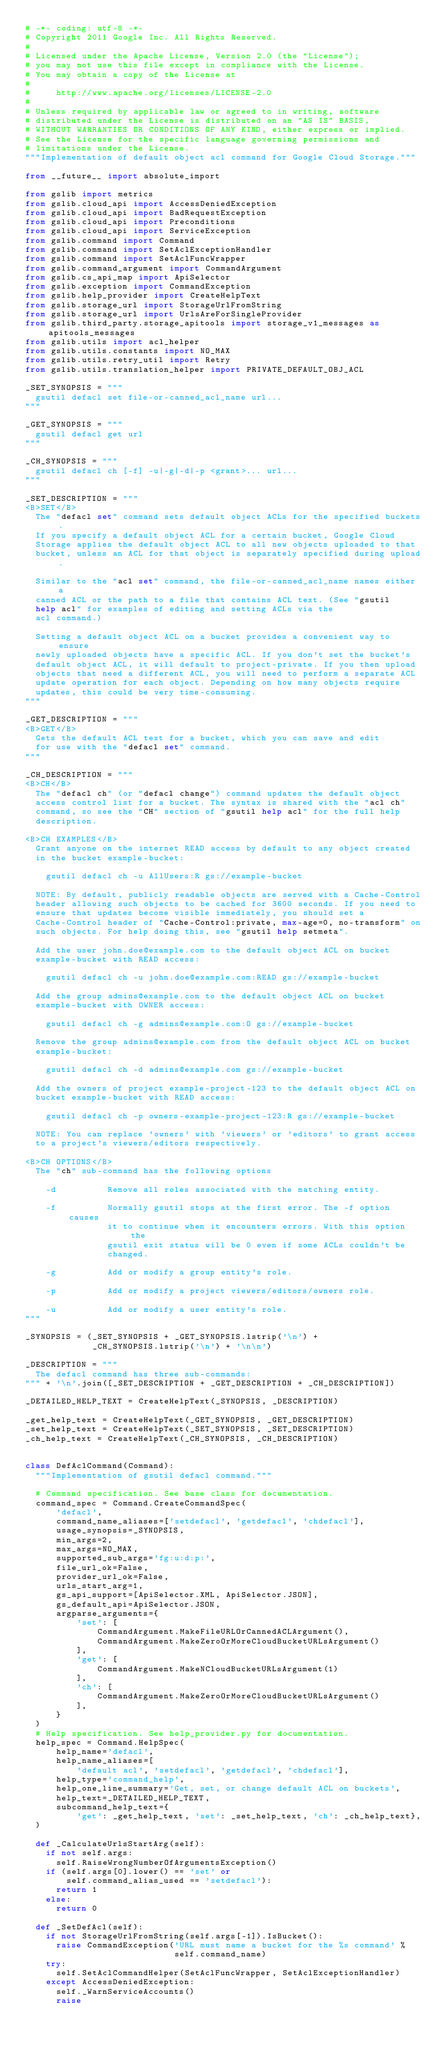<code> <loc_0><loc_0><loc_500><loc_500><_Python_># -*- coding: utf-8 -*-
# Copyright 2011 Google Inc. All Rights Reserved.
#
# Licensed under the Apache License, Version 2.0 (the "License");
# you may not use this file except in compliance with the License.
# You may obtain a copy of the License at
#
#     http://www.apache.org/licenses/LICENSE-2.0
#
# Unless required by applicable law or agreed to in writing, software
# distributed under the License is distributed on an "AS IS" BASIS,
# WITHOUT WARRANTIES OR CONDITIONS OF ANY KIND, either express or implied.
# See the License for the specific language governing permissions and
# limitations under the License.
"""Implementation of default object acl command for Google Cloud Storage."""

from __future__ import absolute_import

from gslib import metrics
from gslib.cloud_api import AccessDeniedException
from gslib.cloud_api import BadRequestException
from gslib.cloud_api import Preconditions
from gslib.cloud_api import ServiceException
from gslib.command import Command
from gslib.command import SetAclExceptionHandler
from gslib.command import SetAclFuncWrapper
from gslib.command_argument import CommandArgument
from gslib.cs_api_map import ApiSelector
from gslib.exception import CommandException
from gslib.help_provider import CreateHelpText
from gslib.storage_url import StorageUrlFromString
from gslib.storage_url import UrlsAreForSingleProvider
from gslib.third_party.storage_apitools import storage_v1_messages as apitools_messages
from gslib.utils import acl_helper
from gslib.utils.constants import NO_MAX
from gslib.utils.retry_util import Retry
from gslib.utils.translation_helper import PRIVATE_DEFAULT_OBJ_ACL

_SET_SYNOPSIS = """
  gsutil defacl set file-or-canned_acl_name url...
"""

_GET_SYNOPSIS = """
  gsutil defacl get url
"""

_CH_SYNOPSIS = """
  gsutil defacl ch [-f] -u|-g|-d|-p <grant>... url...
"""

_SET_DESCRIPTION = """
<B>SET</B>
  The "defacl set" command sets default object ACLs for the specified buckets.
  If you specify a default object ACL for a certain bucket, Google Cloud
  Storage applies the default object ACL to all new objects uploaded to that
  bucket, unless an ACL for that object is separately specified during upload.

  Similar to the "acl set" command, the file-or-canned_acl_name names either a
  canned ACL or the path to a file that contains ACL text. (See "gsutil
  help acl" for examples of editing and setting ACLs via the
  acl command.)

  Setting a default object ACL on a bucket provides a convenient way to ensure
  newly uploaded objects have a specific ACL. If you don't set the bucket's
  default object ACL, it will default to project-private. If you then upload
  objects that need a different ACL, you will need to perform a separate ACL
  update operation for each object. Depending on how many objects require
  updates, this could be very time-consuming.
"""

_GET_DESCRIPTION = """
<B>GET</B>
  Gets the default ACL text for a bucket, which you can save and edit
  for use with the "defacl set" command.
"""

_CH_DESCRIPTION = """
<B>CH</B>
  The "defacl ch" (or "defacl change") command updates the default object
  access control list for a bucket. The syntax is shared with the "acl ch"
  command, so see the "CH" section of "gsutil help acl" for the full help
  description.

<B>CH EXAMPLES</B>
  Grant anyone on the internet READ access by default to any object created
  in the bucket example-bucket:

    gsutil defacl ch -u AllUsers:R gs://example-bucket

  NOTE: By default, publicly readable objects are served with a Cache-Control
  header allowing such objects to be cached for 3600 seconds. If you need to
  ensure that updates become visible immediately, you should set a
  Cache-Control header of "Cache-Control:private, max-age=0, no-transform" on
  such objects. For help doing this, see "gsutil help setmeta".

  Add the user john.doe@example.com to the default object ACL on bucket
  example-bucket with READ access:

    gsutil defacl ch -u john.doe@example.com:READ gs://example-bucket

  Add the group admins@example.com to the default object ACL on bucket
  example-bucket with OWNER access:

    gsutil defacl ch -g admins@example.com:O gs://example-bucket

  Remove the group admins@example.com from the default object ACL on bucket
  example-bucket:

    gsutil defacl ch -d admins@example.com gs://example-bucket

  Add the owners of project example-project-123 to the default object ACL on
  bucket example-bucket with READ access:

    gsutil defacl ch -p owners-example-project-123:R gs://example-bucket

  NOTE: You can replace 'owners' with 'viewers' or 'editors' to grant access
  to a project's viewers/editors respectively.

<B>CH OPTIONS</B>
  The "ch" sub-command has the following options

    -d          Remove all roles associated with the matching entity.

    -f          Normally gsutil stops at the first error. The -f option causes
                it to continue when it encounters errors. With this option the
                gsutil exit status will be 0 even if some ACLs couldn't be
                changed.

    -g          Add or modify a group entity's role.

    -p          Add or modify a project viewers/editors/owners role.

    -u          Add or modify a user entity's role.
"""

_SYNOPSIS = (_SET_SYNOPSIS + _GET_SYNOPSIS.lstrip('\n') +
             _CH_SYNOPSIS.lstrip('\n') + '\n\n')

_DESCRIPTION = """
  The defacl command has three sub-commands:
""" + '\n'.join([_SET_DESCRIPTION + _GET_DESCRIPTION + _CH_DESCRIPTION])

_DETAILED_HELP_TEXT = CreateHelpText(_SYNOPSIS, _DESCRIPTION)

_get_help_text = CreateHelpText(_GET_SYNOPSIS, _GET_DESCRIPTION)
_set_help_text = CreateHelpText(_SET_SYNOPSIS, _SET_DESCRIPTION)
_ch_help_text = CreateHelpText(_CH_SYNOPSIS, _CH_DESCRIPTION)


class DefAclCommand(Command):
  """Implementation of gsutil defacl command."""

  # Command specification. See base class for documentation.
  command_spec = Command.CreateCommandSpec(
      'defacl',
      command_name_aliases=['setdefacl', 'getdefacl', 'chdefacl'],
      usage_synopsis=_SYNOPSIS,
      min_args=2,
      max_args=NO_MAX,
      supported_sub_args='fg:u:d:p:',
      file_url_ok=False,
      provider_url_ok=False,
      urls_start_arg=1,
      gs_api_support=[ApiSelector.XML, ApiSelector.JSON],
      gs_default_api=ApiSelector.JSON,
      argparse_arguments={
          'set': [
              CommandArgument.MakeFileURLOrCannedACLArgument(),
              CommandArgument.MakeZeroOrMoreCloudBucketURLsArgument()
          ],
          'get': [
              CommandArgument.MakeNCloudBucketURLsArgument(1)
          ],
          'ch': [
              CommandArgument.MakeZeroOrMoreCloudBucketURLsArgument()
          ],
      }
  )
  # Help specification. See help_provider.py for documentation.
  help_spec = Command.HelpSpec(
      help_name='defacl',
      help_name_aliases=[
          'default acl', 'setdefacl', 'getdefacl', 'chdefacl'],
      help_type='command_help',
      help_one_line_summary='Get, set, or change default ACL on buckets',
      help_text=_DETAILED_HELP_TEXT,
      subcommand_help_text={
          'get': _get_help_text, 'set': _set_help_text, 'ch': _ch_help_text},
  )

  def _CalculateUrlsStartArg(self):
    if not self.args:
      self.RaiseWrongNumberOfArgumentsException()
    if (self.args[0].lower() == 'set' or
        self.command_alias_used == 'setdefacl'):
      return 1
    else:
      return 0

  def _SetDefAcl(self):
    if not StorageUrlFromString(self.args[-1]).IsBucket():
      raise CommandException('URL must name a bucket for the %s command' %
                             self.command_name)
    try:
      self.SetAclCommandHelper(SetAclFuncWrapper, SetAclExceptionHandler)
    except AccessDeniedException:
      self._WarnServiceAccounts()
      raise
</code> 